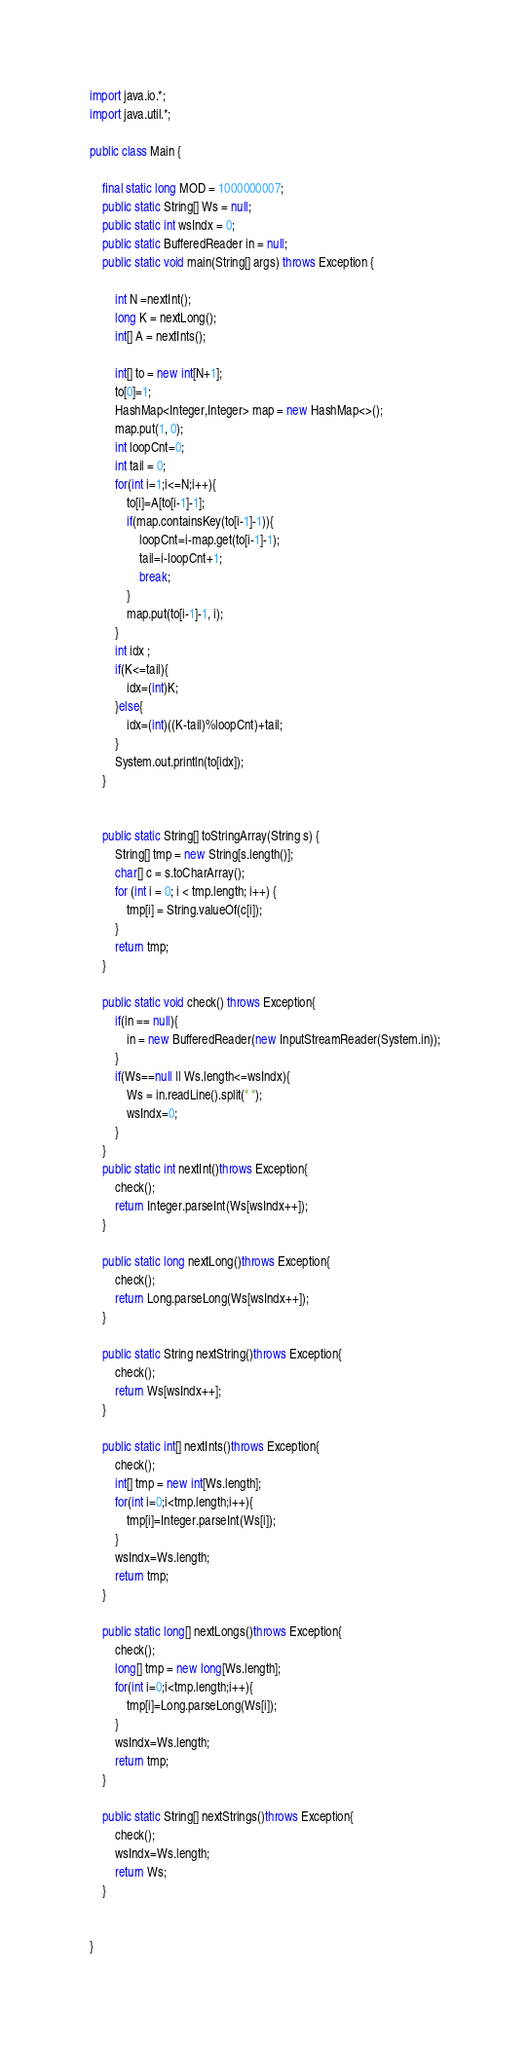<code> <loc_0><loc_0><loc_500><loc_500><_Java_>import java.io.*;
import java.util.*;

public class Main {

	final static long MOD = 1000000007;
	public static String[] Ws = null;
	public static int wsIndx = 0;
	public static BufferedReader in = null;
	public static void main(String[] args) throws Exception {

		int N =nextInt();
		long K = nextLong();
		int[] A = nextInts();

		int[] to = new int[N+1];
		to[0]=1;
		HashMap<Integer,Integer> map = new HashMap<>();
		map.put(1, 0);
		int loopCnt=0;
		int tail = 0;
		for(int i=1;i<=N;i++){
			to[i]=A[to[i-1]-1];
			if(map.containsKey(to[i-1]-1)){
				loopCnt=i-map.get(to[i-1]-1);
				tail=i-loopCnt+1;
				break;
			}
			map.put(to[i-1]-1, i);
		}
		int idx ;
		if(K<=tail){
			idx=(int)K;
		}else{
			idx=(int)((K-tail)%loopCnt)+tail;
		}
		System.out.println(to[idx]);
	}


	public static String[] toStringArray(String s) {
		String[] tmp = new String[s.length()];
		char[] c = s.toCharArray();
		for (int i = 0; i < tmp.length; i++) {
			tmp[i] = String.valueOf(c[i]);
		}
		return tmp;
	}

	public static void check() throws Exception{
		if(in == null){
			in = new BufferedReader(new InputStreamReader(System.in));
		}
		if(Ws==null || Ws.length<=wsIndx){
			Ws = in.readLine().split(" ");
			wsIndx=0;
		}
	}
	public static int nextInt()throws Exception{
		check();
		return Integer.parseInt(Ws[wsIndx++]);
	}

	public static long nextLong()throws Exception{
		check();
		return Long.parseLong(Ws[wsIndx++]);
	}

	public static String nextString()throws Exception{
		check();
		return Ws[wsIndx++];
	}

	public static int[] nextInts()throws Exception{
		check();
		int[] tmp = new int[Ws.length];
		for(int i=0;i<tmp.length;i++){
			tmp[i]=Integer.parseInt(Ws[i]);
		}
		wsIndx=Ws.length;
		return tmp;
	}

	public static long[] nextLongs()throws Exception{
		check();
		long[] tmp = new long[Ws.length];
		for(int i=0;i<tmp.length;i++){
			tmp[i]=Long.parseLong(Ws[i]);
		}
		wsIndx=Ws.length;
		return tmp;
	}

	public static String[] nextStrings()throws Exception{
		check();
		wsIndx=Ws.length;
		return Ws;
	}


}
</code> 